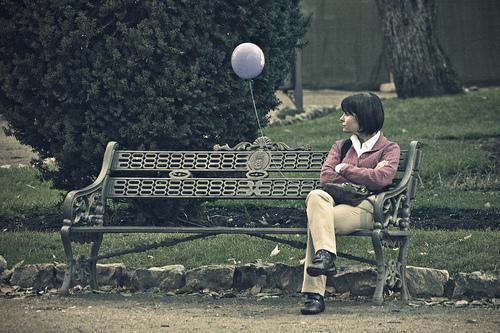How many people are on the bench?
Give a very brief answer. 1. 